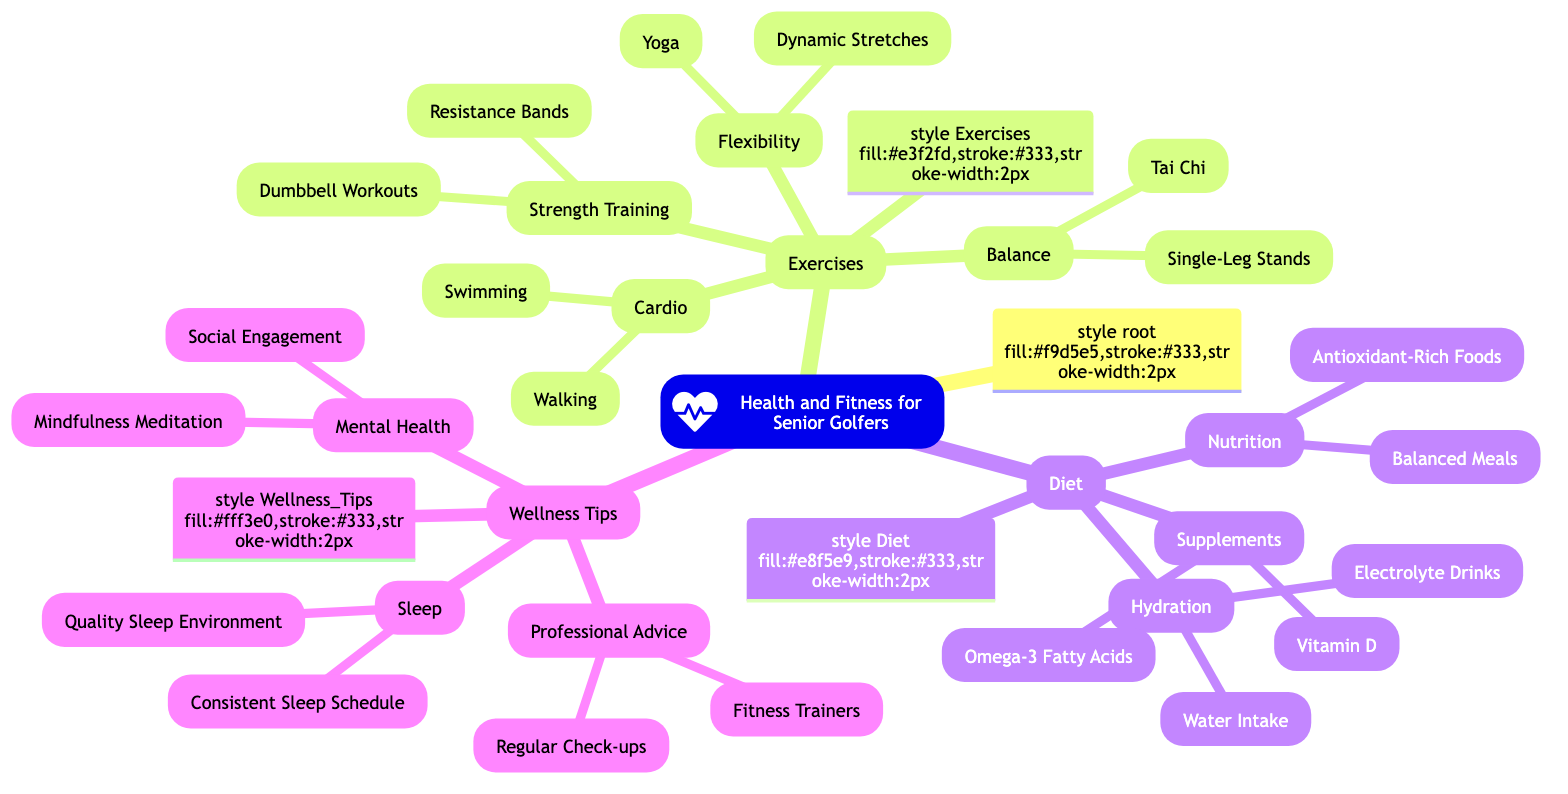What is the main topic of the mind map? The center node is labeled "Health and Fitness for Senior Golfers," which indicates the primary subject of the mind map.
Answer: Health and Fitness for Senior Golfers How many main categories are presented in the diagram? There are four primary categories shown in the mind map: Exercises, Diet, Wellness Tips, and each category directly branches from the main topic.
Answer: 3 Which exercise focuses on improving flexibility? Under the category "Flexibility," there are two exercises listed: "Dynamic Stretches" and "Yoga," both aimed at enhancing flexibility.
Answer: Dynamic Stretches What type of diet emphasizes the importance of hydration? The section labeled "Hydration" within the "Diet" category indicates the focus on liquid intake, including aspects like water and electrolyte drinks.
Answer: Hydration What exercises are suggested for balance improvement? The "Balance" category contains "Single-Leg Stands" and "Tai Chi," which are specifically aimed at enhancing balance.
Answer: Single-Leg Stands Which wellness tip is recommended for better sleep? In the "Sleep" section, the emphasis on maintaining a "Consistent Sleep Schedule" is presented as a tip for improving sleep quality.
Answer: Consistent Sleep Schedule What type of foods are included for nutritional benefits? The "Nutrition" category outlines "Balanced Meals" and "Antioxidant-Rich Foods," thus emphasizing the inclusion of healthy food types.
Answer: Balanced Meals How many exercises focus on cardio? The "Cardio" section includes two exercises: "Walking" and "Swimming," which indicates there are two specific cardio exercises in total.
Answer: 2 What professional advice is suggested regarding fitness training? The "Professional Advice" section mentions "Fitness Trainers" as a recommended resource for seniors looking to improve their fitness.
Answer: Fitness Trainers 